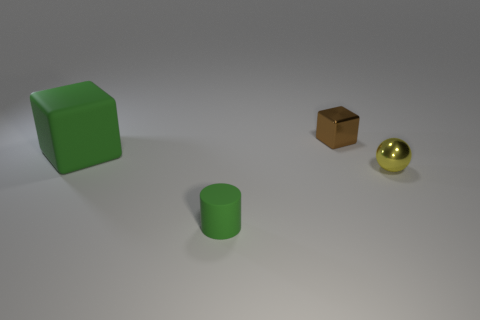Add 2 small yellow shiny balls. How many objects exist? 6 Subtract all cylinders. How many objects are left? 3 Subtract all big cubes. Subtract all small brown blocks. How many objects are left? 2 Add 3 small green matte cylinders. How many small green matte cylinders are left? 4 Add 4 matte cubes. How many matte cubes exist? 5 Subtract 0 cyan spheres. How many objects are left? 4 